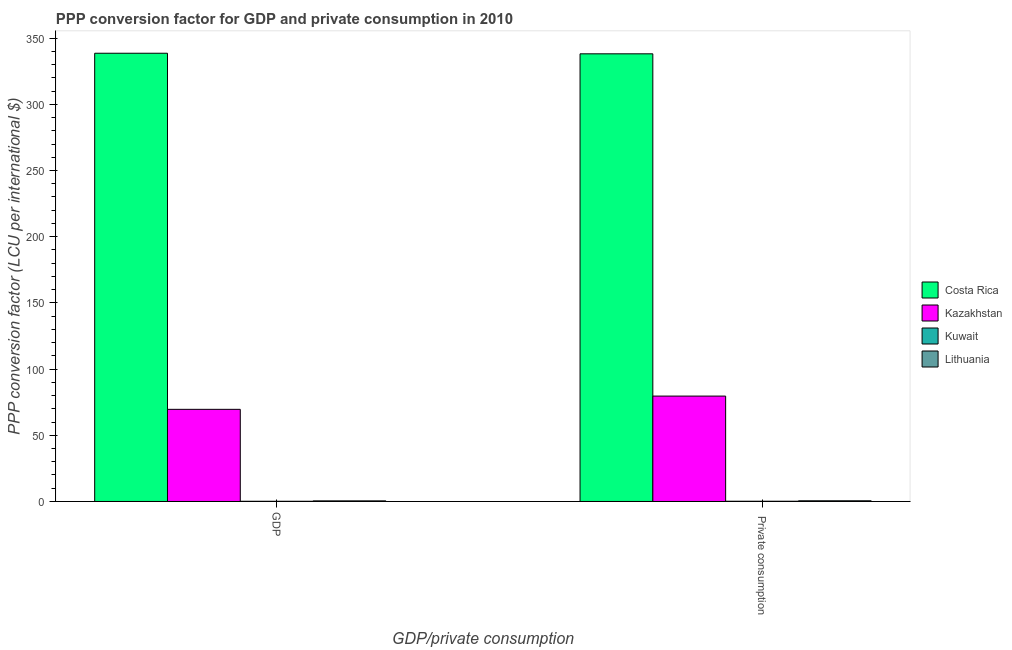Are the number of bars on each tick of the X-axis equal?
Your answer should be compact. Yes. How many bars are there on the 2nd tick from the right?
Make the answer very short. 4. What is the label of the 1st group of bars from the left?
Ensure brevity in your answer.  GDP. What is the ppp conversion factor for private consumption in Kuwait?
Your answer should be compact. 0.18. Across all countries, what is the maximum ppp conversion factor for private consumption?
Keep it short and to the point. 338.13. Across all countries, what is the minimum ppp conversion factor for gdp?
Your answer should be very brief. 0.15. In which country was the ppp conversion factor for private consumption minimum?
Keep it short and to the point. Kuwait. What is the total ppp conversion factor for private consumption in the graph?
Offer a very short reply. 418.43. What is the difference between the ppp conversion factor for private consumption in Kuwait and that in Costa Rica?
Make the answer very short. -337.95. What is the difference between the ppp conversion factor for gdp in Kuwait and the ppp conversion factor for private consumption in Lithuania?
Your answer should be very brief. -0.37. What is the average ppp conversion factor for gdp per country?
Offer a very short reply. 102.19. What is the difference between the ppp conversion factor for private consumption and ppp conversion factor for gdp in Kuwait?
Keep it short and to the point. 0.03. What is the ratio of the ppp conversion factor for gdp in Costa Rica to that in Kuwait?
Make the answer very short. 2261.01. What does the 4th bar from the left in  Private consumption represents?
Offer a very short reply. Lithuania. What does the 3rd bar from the right in GDP represents?
Keep it short and to the point. Kazakhstan. How many bars are there?
Ensure brevity in your answer.  8. How many countries are there in the graph?
Give a very brief answer. 4. Are the values on the major ticks of Y-axis written in scientific E-notation?
Ensure brevity in your answer.  No. Does the graph contain any zero values?
Make the answer very short. No. How many legend labels are there?
Offer a very short reply. 4. How are the legend labels stacked?
Offer a very short reply. Vertical. What is the title of the graph?
Your answer should be very brief. PPP conversion factor for GDP and private consumption in 2010. What is the label or title of the X-axis?
Offer a terse response. GDP/private consumption. What is the label or title of the Y-axis?
Provide a short and direct response. PPP conversion factor (LCU per international $). What is the PPP conversion factor (LCU per international $) in Costa Rica in GDP?
Provide a succinct answer. 338.57. What is the PPP conversion factor (LCU per international $) in Kazakhstan in GDP?
Ensure brevity in your answer.  69.6. What is the PPP conversion factor (LCU per international $) of Kuwait in GDP?
Keep it short and to the point. 0.15. What is the PPP conversion factor (LCU per international $) of Lithuania in GDP?
Offer a very short reply. 0.45. What is the PPP conversion factor (LCU per international $) of Costa Rica in  Private consumption?
Offer a very short reply. 338.13. What is the PPP conversion factor (LCU per international $) of Kazakhstan in  Private consumption?
Ensure brevity in your answer.  79.61. What is the PPP conversion factor (LCU per international $) in Kuwait in  Private consumption?
Your answer should be compact. 0.18. What is the PPP conversion factor (LCU per international $) of Lithuania in  Private consumption?
Your answer should be compact. 0.52. Across all GDP/private consumption, what is the maximum PPP conversion factor (LCU per international $) of Costa Rica?
Your answer should be compact. 338.57. Across all GDP/private consumption, what is the maximum PPP conversion factor (LCU per international $) in Kazakhstan?
Ensure brevity in your answer.  79.61. Across all GDP/private consumption, what is the maximum PPP conversion factor (LCU per international $) of Kuwait?
Offer a very short reply. 0.18. Across all GDP/private consumption, what is the maximum PPP conversion factor (LCU per international $) of Lithuania?
Your response must be concise. 0.52. Across all GDP/private consumption, what is the minimum PPP conversion factor (LCU per international $) of Costa Rica?
Your answer should be very brief. 338.13. Across all GDP/private consumption, what is the minimum PPP conversion factor (LCU per international $) of Kazakhstan?
Keep it short and to the point. 69.6. Across all GDP/private consumption, what is the minimum PPP conversion factor (LCU per international $) of Kuwait?
Offer a terse response. 0.15. Across all GDP/private consumption, what is the minimum PPP conversion factor (LCU per international $) of Lithuania?
Ensure brevity in your answer.  0.45. What is the total PPP conversion factor (LCU per international $) in Costa Rica in the graph?
Offer a terse response. 676.7. What is the total PPP conversion factor (LCU per international $) in Kazakhstan in the graph?
Ensure brevity in your answer.  149.2. What is the total PPP conversion factor (LCU per international $) of Kuwait in the graph?
Make the answer very short. 0.33. What is the total PPP conversion factor (LCU per international $) of Lithuania in the graph?
Offer a terse response. 0.97. What is the difference between the PPP conversion factor (LCU per international $) in Costa Rica in GDP and that in  Private consumption?
Your answer should be compact. 0.44. What is the difference between the PPP conversion factor (LCU per international $) of Kazakhstan in GDP and that in  Private consumption?
Give a very brief answer. -10.01. What is the difference between the PPP conversion factor (LCU per international $) in Kuwait in GDP and that in  Private consumption?
Your answer should be compact. -0.03. What is the difference between the PPP conversion factor (LCU per international $) of Lithuania in GDP and that in  Private consumption?
Make the answer very short. -0.07. What is the difference between the PPP conversion factor (LCU per international $) of Costa Rica in GDP and the PPP conversion factor (LCU per international $) of Kazakhstan in  Private consumption?
Provide a short and direct response. 258.96. What is the difference between the PPP conversion factor (LCU per international $) of Costa Rica in GDP and the PPP conversion factor (LCU per international $) of Kuwait in  Private consumption?
Your answer should be very brief. 338.39. What is the difference between the PPP conversion factor (LCU per international $) in Costa Rica in GDP and the PPP conversion factor (LCU per international $) in Lithuania in  Private consumption?
Your answer should be very brief. 338.05. What is the difference between the PPP conversion factor (LCU per international $) in Kazakhstan in GDP and the PPP conversion factor (LCU per international $) in Kuwait in  Private consumption?
Keep it short and to the point. 69.42. What is the difference between the PPP conversion factor (LCU per international $) of Kazakhstan in GDP and the PPP conversion factor (LCU per international $) of Lithuania in  Private consumption?
Your answer should be very brief. 69.08. What is the difference between the PPP conversion factor (LCU per international $) of Kuwait in GDP and the PPP conversion factor (LCU per international $) of Lithuania in  Private consumption?
Your answer should be compact. -0.37. What is the average PPP conversion factor (LCU per international $) of Costa Rica per GDP/private consumption?
Give a very brief answer. 338.35. What is the average PPP conversion factor (LCU per international $) in Kazakhstan per GDP/private consumption?
Provide a succinct answer. 74.6. What is the average PPP conversion factor (LCU per international $) of Kuwait per GDP/private consumption?
Your response must be concise. 0.16. What is the average PPP conversion factor (LCU per international $) of Lithuania per GDP/private consumption?
Your response must be concise. 0.48. What is the difference between the PPP conversion factor (LCU per international $) of Costa Rica and PPP conversion factor (LCU per international $) of Kazakhstan in GDP?
Provide a short and direct response. 268.97. What is the difference between the PPP conversion factor (LCU per international $) of Costa Rica and PPP conversion factor (LCU per international $) of Kuwait in GDP?
Ensure brevity in your answer.  338.42. What is the difference between the PPP conversion factor (LCU per international $) in Costa Rica and PPP conversion factor (LCU per international $) in Lithuania in GDP?
Your answer should be compact. 338.12. What is the difference between the PPP conversion factor (LCU per international $) of Kazakhstan and PPP conversion factor (LCU per international $) of Kuwait in GDP?
Give a very brief answer. 69.45. What is the difference between the PPP conversion factor (LCU per international $) in Kazakhstan and PPP conversion factor (LCU per international $) in Lithuania in GDP?
Your answer should be compact. 69.15. What is the difference between the PPP conversion factor (LCU per international $) of Kuwait and PPP conversion factor (LCU per international $) of Lithuania in GDP?
Give a very brief answer. -0.3. What is the difference between the PPP conversion factor (LCU per international $) of Costa Rica and PPP conversion factor (LCU per international $) of Kazakhstan in  Private consumption?
Make the answer very short. 258.52. What is the difference between the PPP conversion factor (LCU per international $) in Costa Rica and PPP conversion factor (LCU per international $) in Kuwait in  Private consumption?
Give a very brief answer. 337.95. What is the difference between the PPP conversion factor (LCU per international $) of Costa Rica and PPP conversion factor (LCU per international $) of Lithuania in  Private consumption?
Your answer should be very brief. 337.61. What is the difference between the PPP conversion factor (LCU per international $) of Kazakhstan and PPP conversion factor (LCU per international $) of Kuwait in  Private consumption?
Your answer should be compact. 79.43. What is the difference between the PPP conversion factor (LCU per international $) of Kazakhstan and PPP conversion factor (LCU per international $) of Lithuania in  Private consumption?
Offer a terse response. 79.09. What is the difference between the PPP conversion factor (LCU per international $) in Kuwait and PPP conversion factor (LCU per international $) in Lithuania in  Private consumption?
Your response must be concise. -0.34. What is the ratio of the PPP conversion factor (LCU per international $) of Costa Rica in GDP to that in  Private consumption?
Make the answer very short. 1. What is the ratio of the PPP conversion factor (LCU per international $) in Kazakhstan in GDP to that in  Private consumption?
Provide a short and direct response. 0.87. What is the ratio of the PPP conversion factor (LCU per international $) in Kuwait in GDP to that in  Private consumption?
Give a very brief answer. 0.84. What is the ratio of the PPP conversion factor (LCU per international $) in Lithuania in GDP to that in  Private consumption?
Keep it short and to the point. 0.87. What is the difference between the highest and the second highest PPP conversion factor (LCU per international $) of Costa Rica?
Give a very brief answer. 0.44. What is the difference between the highest and the second highest PPP conversion factor (LCU per international $) in Kazakhstan?
Offer a terse response. 10.01. What is the difference between the highest and the second highest PPP conversion factor (LCU per international $) of Kuwait?
Your response must be concise. 0.03. What is the difference between the highest and the second highest PPP conversion factor (LCU per international $) in Lithuania?
Offer a terse response. 0.07. What is the difference between the highest and the lowest PPP conversion factor (LCU per international $) of Costa Rica?
Keep it short and to the point. 0.44. What is the difference between the highest and the lowest PPP conversion factor (LCU per international $) in Kazakhstan?
Your answer should be compact. 10.01. What is the difference between the highest and the lowest PPP conversion factor (LCU per international $) of Kuwait?
Your answer should be very brief. 0.03. What is the difference between the highest and the lowest PPP conversion factor (LCU per international $) in Lithuania?
Offer a very short reply. 0.07. 